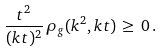Convert formula to latex. <formula><loc_0><loc_0><loc_500><loc_500>\frac { t ^ { 2 } } { ( k t ) ^ { 2 } } \, \rho _ { g } ( k ^ { 2 } , k t ) \, \geq \, 0 \, .</formula> 